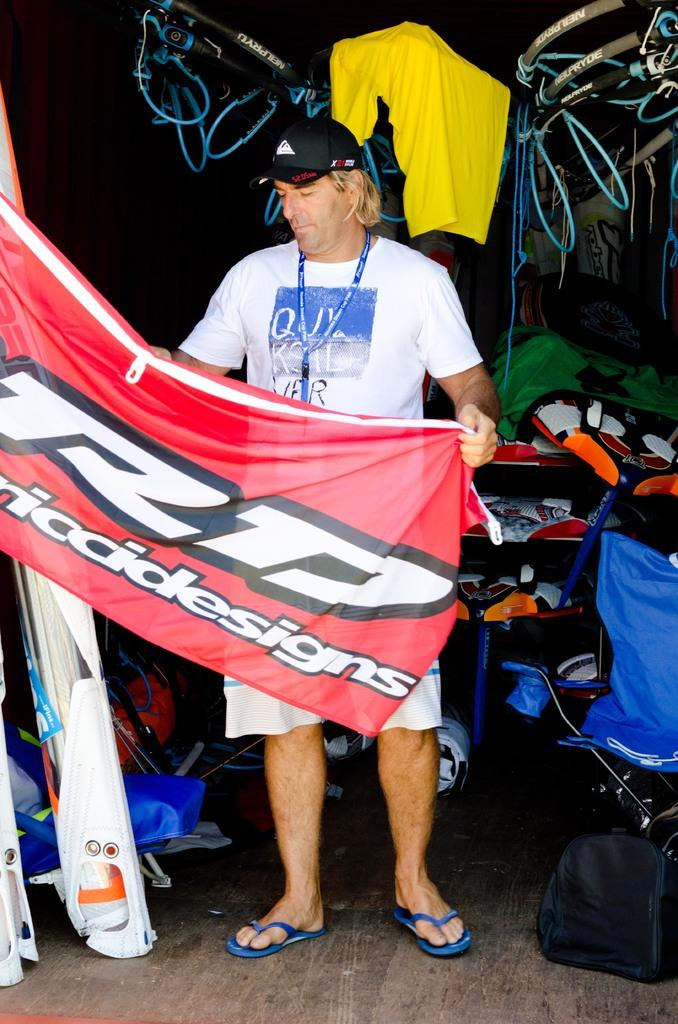<image>
Write a terse but informative summary of the picture. Ricci Designs sponsored this man's group's athletic endeavors. 